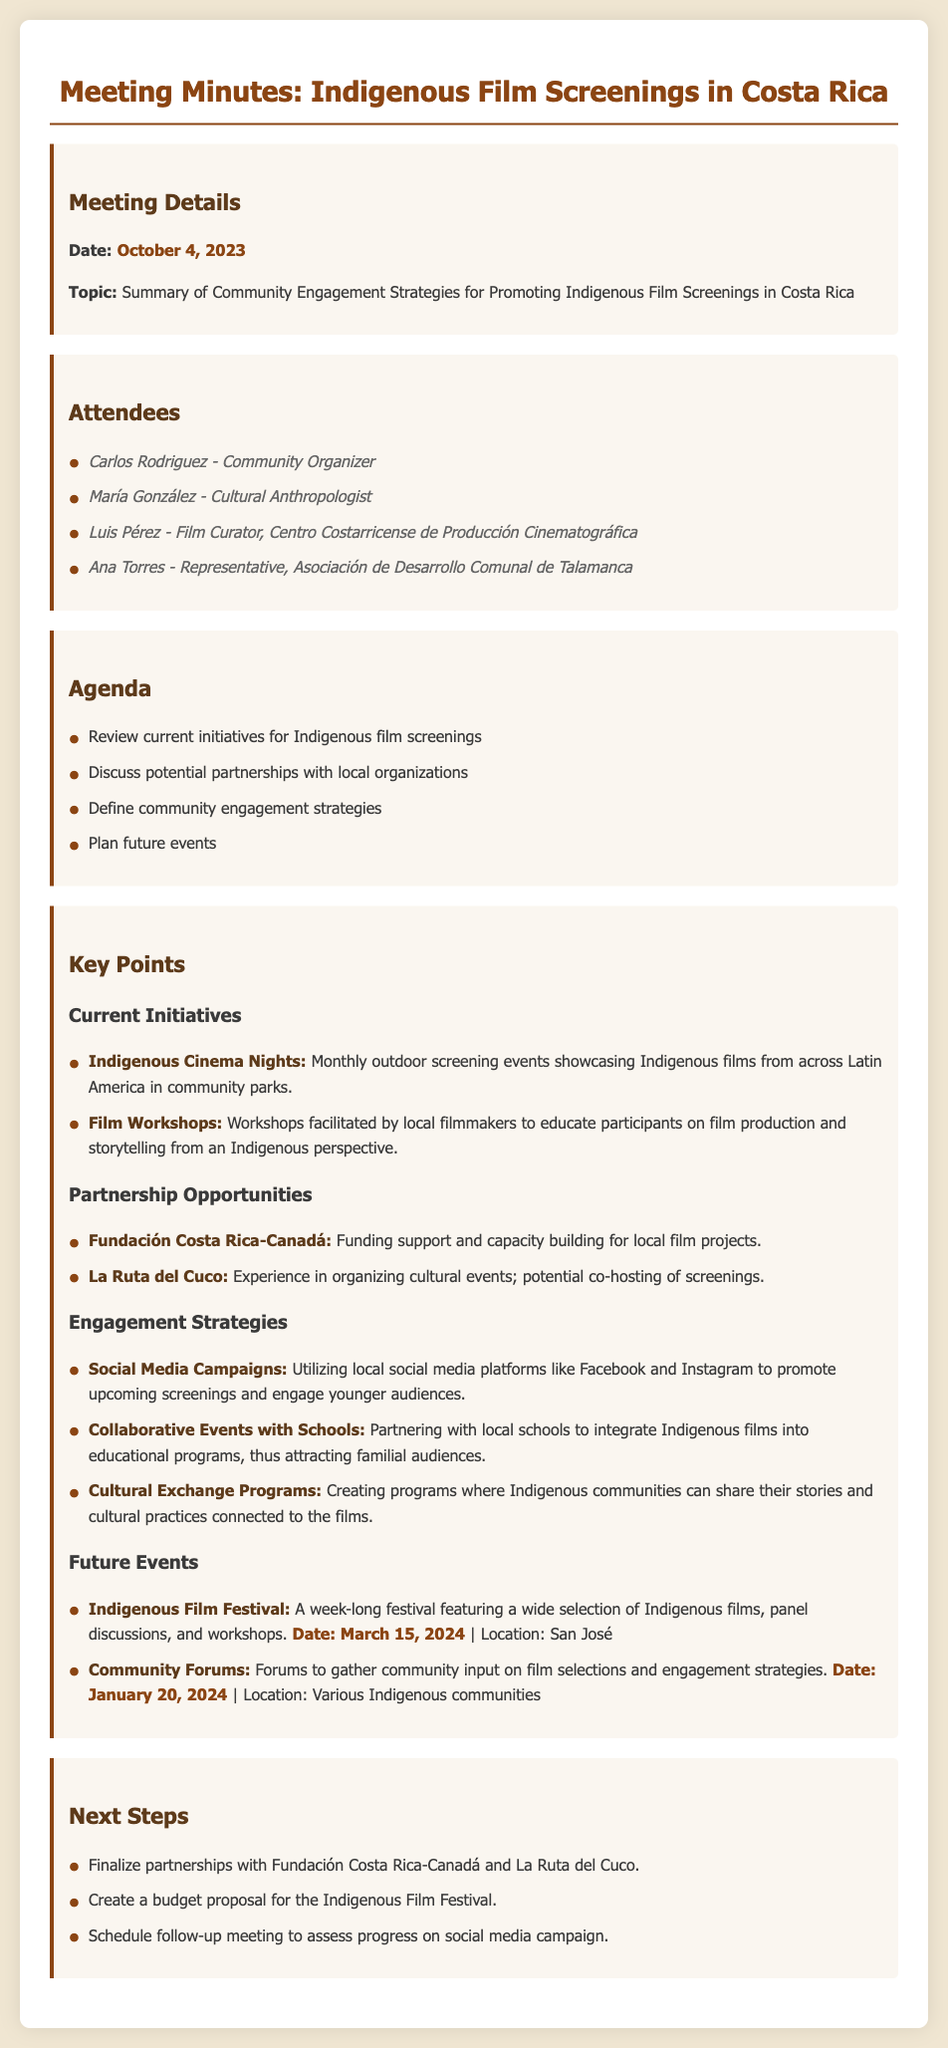what is the date of the meeting? The date of the meeting is mentioned under Meeting Details.
Answer: October 4, 2023 who is the representative from Asociación de Desarrollo Comunal de Talamanca? The attendee list specifies the representative from Asociación de Desarrollo Comunal de Talamanca.
Answer: Ana Torres what is one of the current initiatives for Indigenous film screenings? The Key Points section lists current initiatives, one of which is Indigenous Cinema Nights.
Answer: Indigenous Cinema Nights what organization is involved in funding support for local film projects? The Partnership Opportunities section mentions organizations involved, including the one providing funding support.
Answer: Fundación Costa Rica-Canadá what is one of the future events planned? The Key Points section lists future events, one of which is the Indigenous Film Festival.
Answer: Indigenous Film Festival how often do the Indigenous Cinema Nights occur? The description in the Key Points section indicates the frequency of the Indigenous Cinema Nights.
Answer: Monthly what date is the Indigenous Film Festival scheduled for? The future events section provides the date for the Indigenous Film Festival.
Answer: March 15, 2024 which strategy involves partnering with schools? The Engagement Strategies section includes a strategy that specifically mentions schools.
Answer: Collaborative Events with Schools what initiative features workshops facilitated by local filmmakers? The Key Points section describes an initiative that includes workshops.
Answer: Film Workshops 